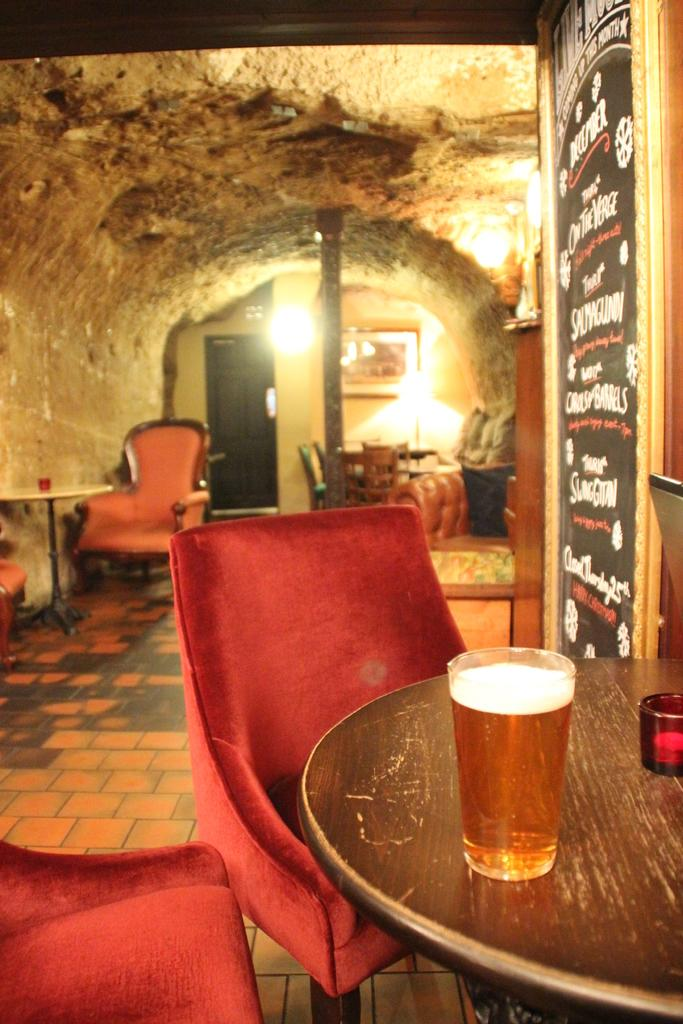What type of furniture is present in the image? There is a chair and a table in the image. What can be seen on the table? There is a glass on the table in the image. What is illuminating the room in the image? There are lights on the wall in the image. Can you see the aunt smoking a pipe in the image? There is no aunt or pipe present in the image. How does the wind affect the objects in the image? There is no wind present in the image, so it cannot affect the objects. 